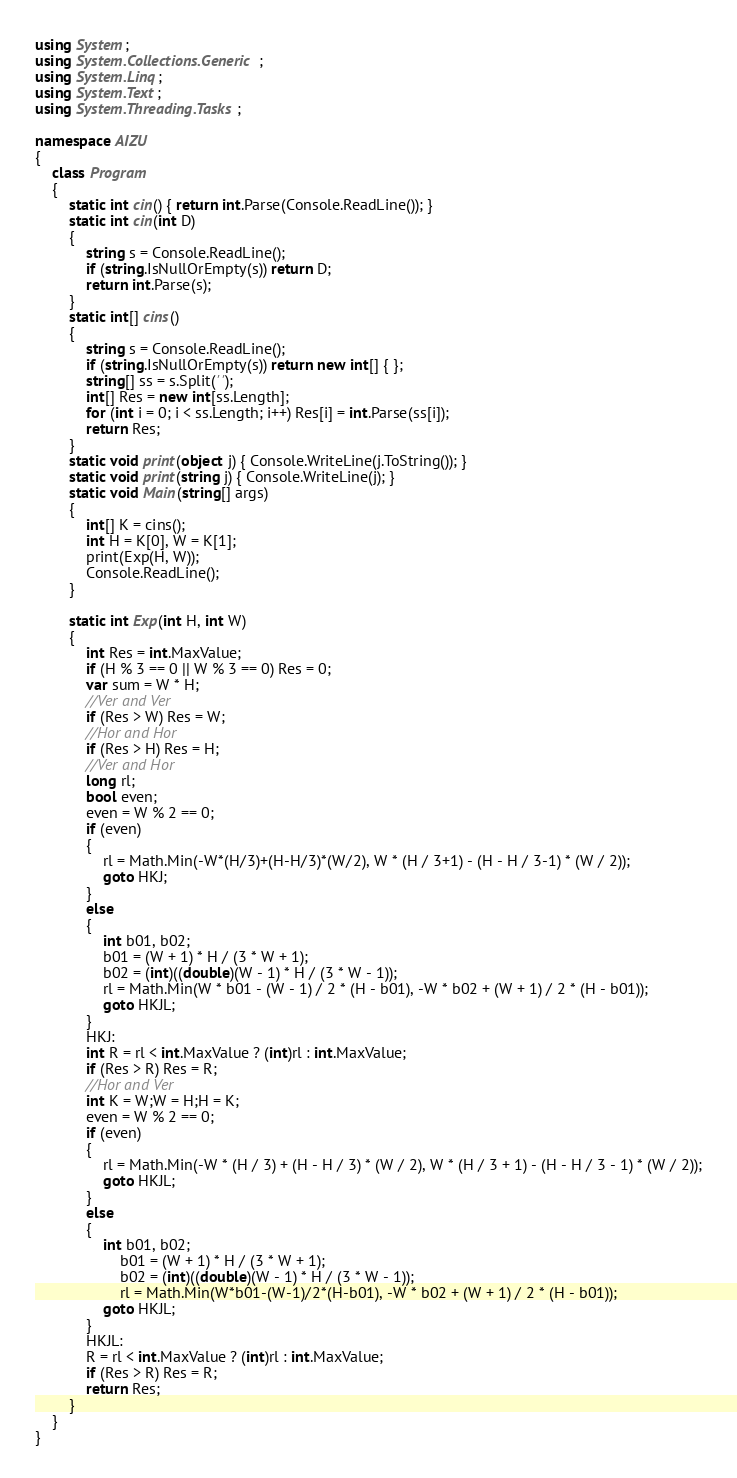<code> <loc_0><loc_0><loc_500><loc_500><_C#_>using System;
using System.Collections.Generic;
using System.Linq;
using System.Text;
using System.Threading.Tasks;

namespace AIZU
{
    class Program
    {
        static int cin() { return int.Parse(Console.ReadLine()); }
        static int cin(int D)
        {
            string s = Console.ReadLine();
            if (string.IsNullOrEmpty(s)) return D;
            return int.Parse(s);
        }
        static int[] cins()
        {
            string s = Console.ReadLine();
            if (string.IsNullOrEmpty(s)) return new int[] { };
            string[] ss = s.Split(' ');
            int[] Res = new int[ss.Length];
            for (int i = 0; i < ss.Length; i++) Res[i] = int.Parse(ss[i]);
            return Res;
        }
        static void print(object j) { Console.WriteLine(j.ToString()); }
        static void print(string j) { Console.WriteLine(j); }
        static void Main(string[] args)
        {
            int[] K = cins();
            int H = K[0], W = K[1];
            print(Exp(H, W));
            Console.ReadLine();
        }

        static int Exp(int H, int W)
        {
            int Res = int.MaxValue;
            if (H % 3 == 0 || W % 3 == 0) Res = 0;
            var sum = W * H;
            //Ver and Ver
            if (Res > W) Res = W;
            //Hor and Hor
            if (Res > H) Res = H;
            //Ver and Hor
            long rl;
            bool even;
            even = W % 2 == 0;
            if (even)
            {
                rl = Math.Min(-W*(H/3)+(H-H/3)*(W/2), W * (H / 3+1) - (H - H / 3-1) * (W / 2));
                goto HKJ;
            }
            else
            {
                int b01, b02;
                b01 = (W + 1) * H / (3 * W + 1);
                b02 = (int)((double)(W - 1) * H / (3 * W - 1));
                rl = Math.Min(W * b01 - (W - 1) / 2 * (H - b01), -W * b02 + (W + 1) / 2 * (H - b01));
                goto HKJL;
            }
            HKJ:
            int R = rl < int.MaxValue ? (int)rl : int.MaxValue;
            if (Res > R) Res = R;
            //Hor and Ver
            int K = W;W = H;H = K;
            even = W % 2 == 0;
            if (even)
            {
                rl = Math.Min(-W * (H / 3) + (H - H / 3) * (W / 2), W * (H / 3 + 1) - (H - H / 3 - 1) * (W / 2));
                goto HKJL;
            }
            else
            {
                int b01, b02;
                    b01 = (W + 1) * H / (3 * W + 1);
                    b02 = (int)((double)(W - 1) * H / (3 * W - 1));
                    rl = Math.Min(W*b01-(W-1)/2*(H-b01), -W * b02 + (W + 1) / 2 * (H - b01));
                goto HKJL;
            }
            HKJL:
            R = rl < int.MaxValue ? (int)rl : int.MaxValue;
            if (Res > R) Res = R;
            return Res;
        }
    }
}
</code> 